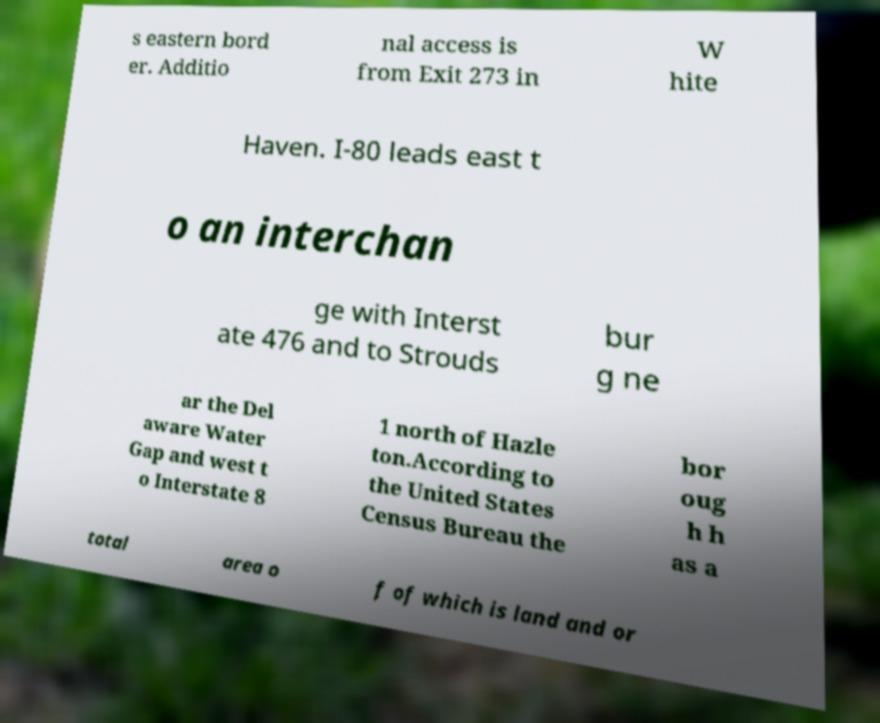For documentation purposes, I need the text within this image transcribed. Could you provide that? s eastern bord er. Additio nal access is from Exit 273 in W hite Haven. I-80 leads east t o an interchan ge with Interst ate 476 and to Strouds bur g ne ar the Del aware Water Gap and west t o Interstate 8 1 north of Hazle ton.According to the United States Census Bureau the bor oug h h as a total area o f of which is land and or 